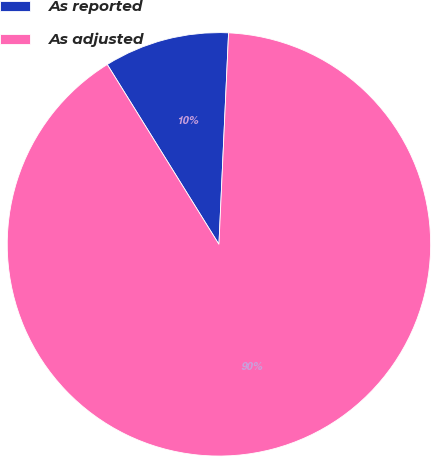<chart> <loc_0><loc_0><loc_500><loc_500><pie_chart><fcel>As reported<fcel>As adjusted<nl><fcel>9.57%<fcel>90.43%<nl></chart> 